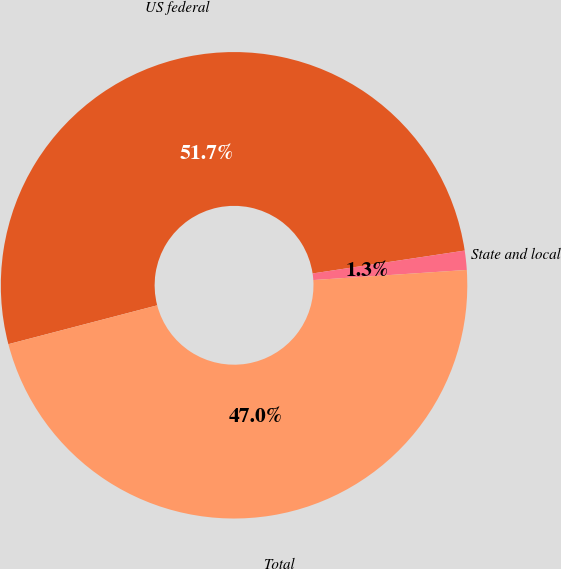Convert chart. <chart><loc_0><loc_0><loc_500><loc_500><pie_chart><fcel>US federal<fcel>State and local<fcel>Total<nl><fcel>51.68%<fcel>1.33%<fcel>46.98%<nl></chart> 